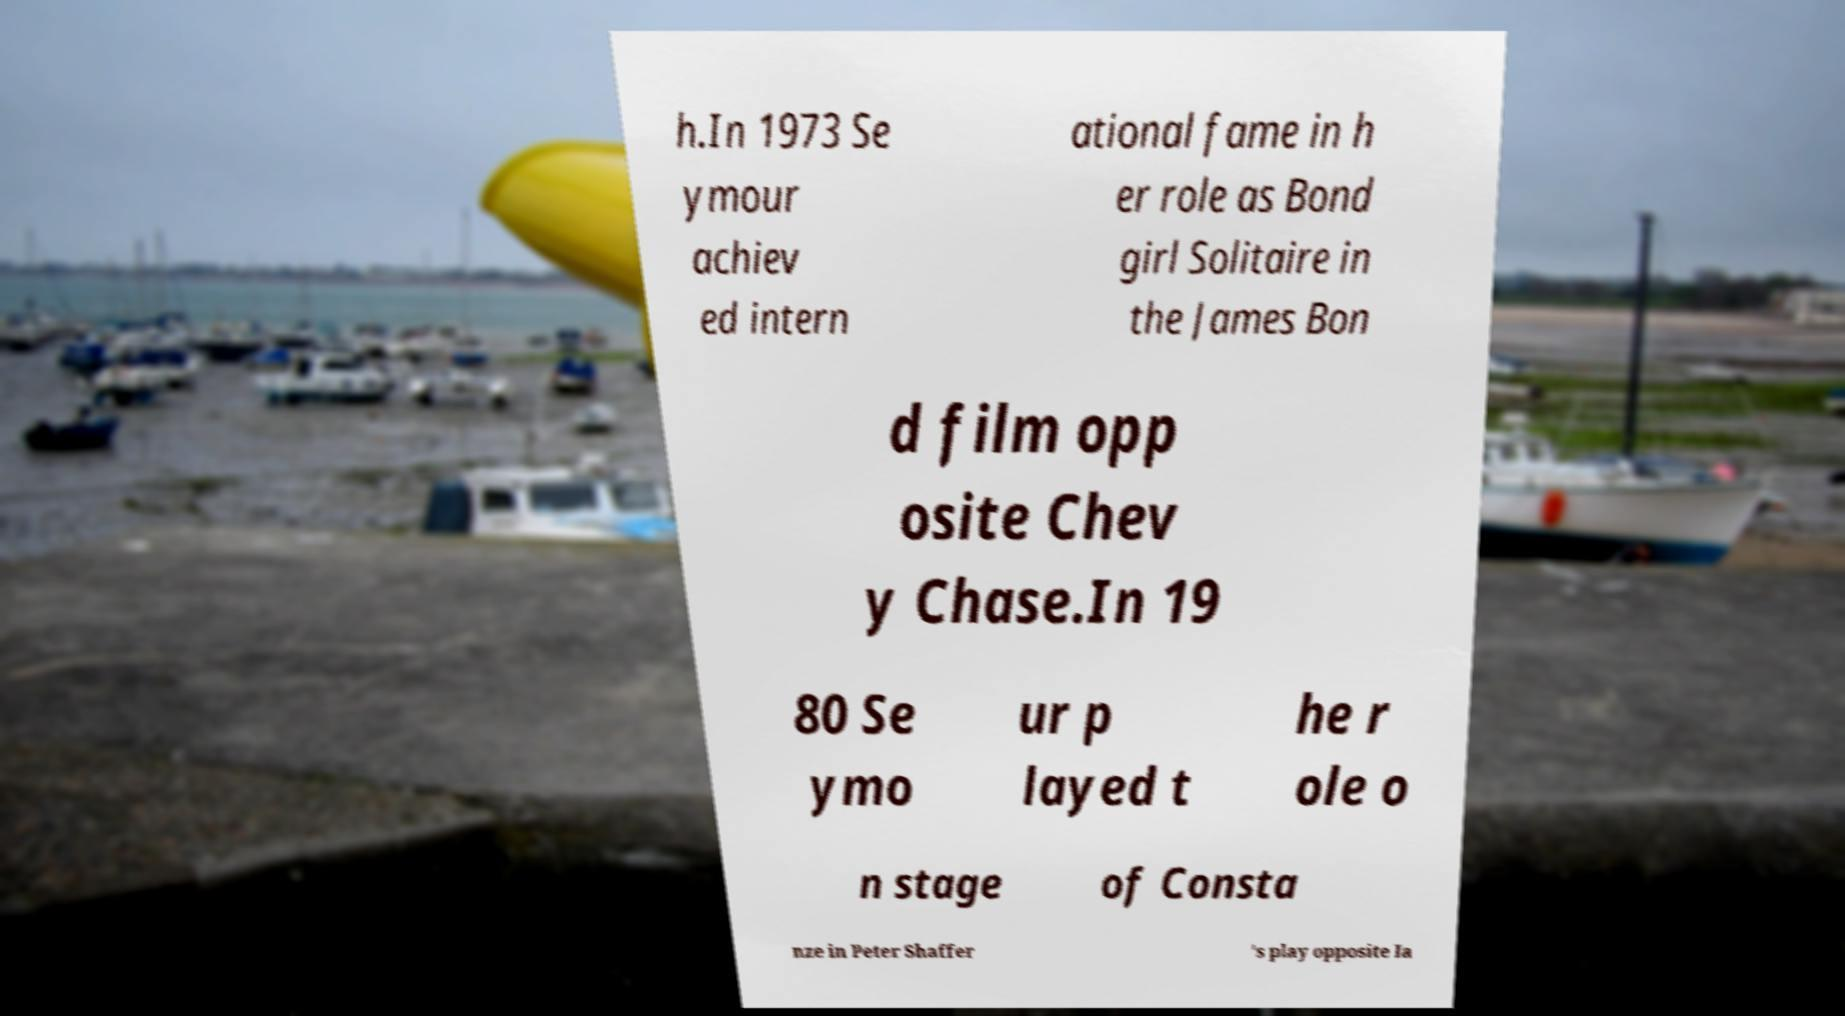I need the written content from this picture converted into text. Can you do that? h.In 1973 Se ymour achiev ed intern ational fame in h er role as Bond girl Solitaire in the James Bon d film opp osite Chev y Chase.In 19 80 Se ymo ur p layed t he r ole o n stage of Consta nze in Peter Shaffer 's play opposite Ia 